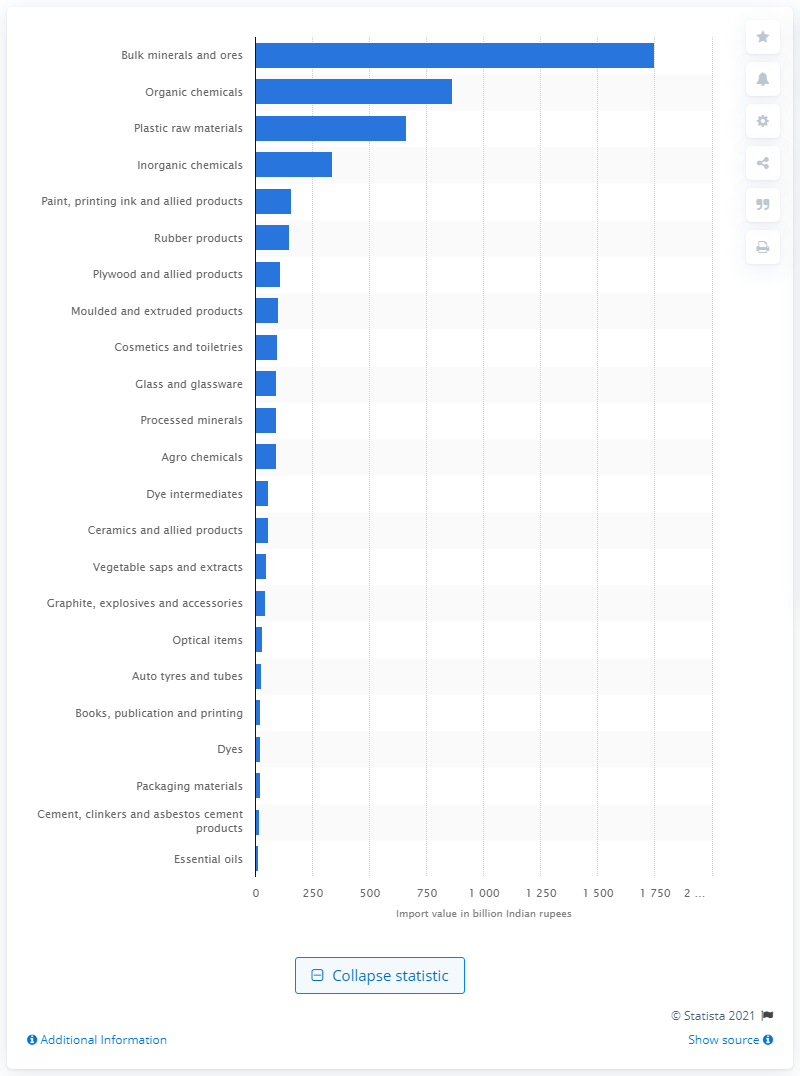Mention a couple of crucial points in this snapshot. According to the latest fiscal year 2020 data, the highest import value of chemicals into India was recorded, with bulk minerals and ores being the primary import item. 